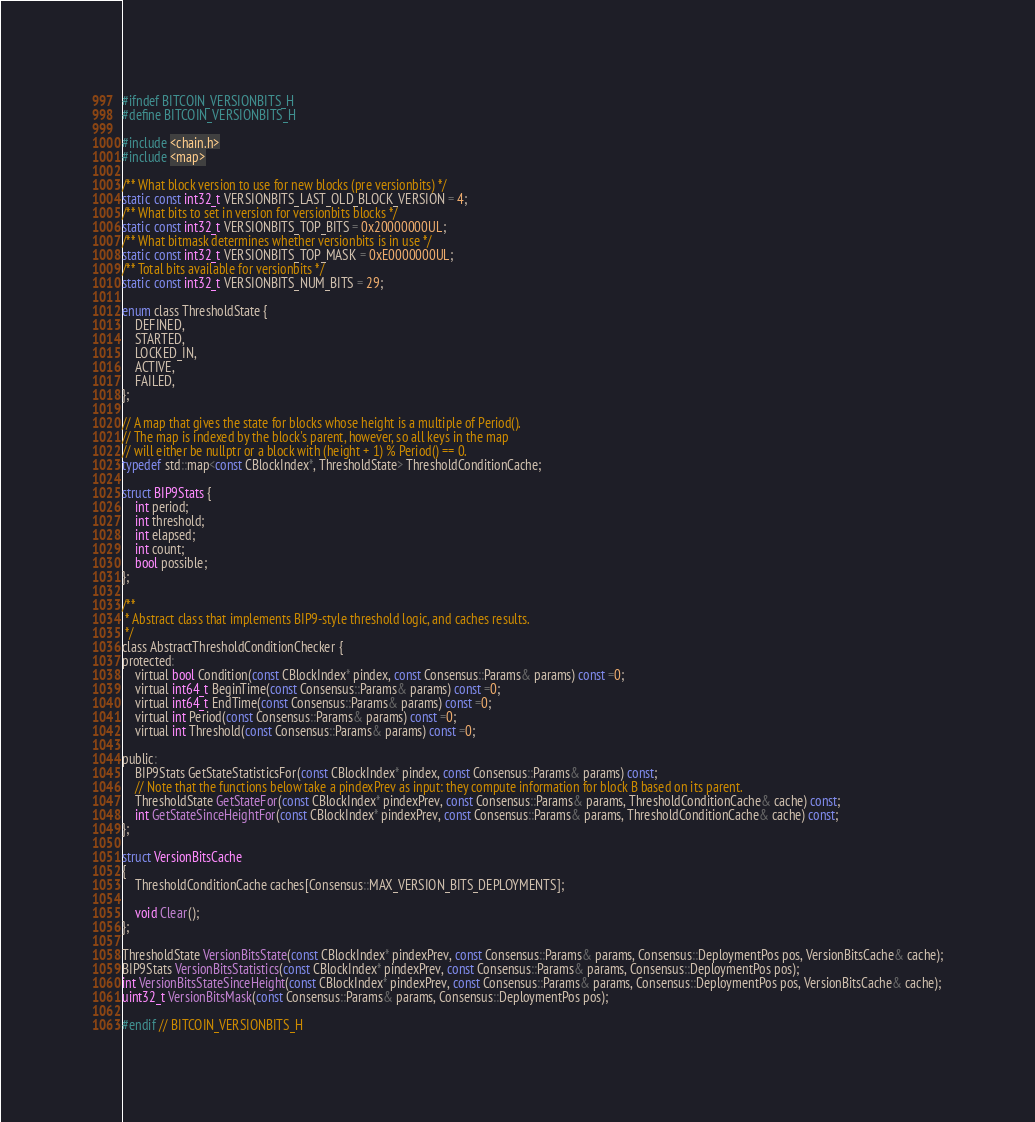Convert code to text. <code><loc_0><loc_0><loc_500><loc_500><_C_>
#ifndef BITCOIN_VERSIONBITS_H
#define BITCOIN_VERSIONBITS_H

#include <chain.h>
#include <map>

/** What block version to use for new blocks (pre versionbits) */
static const int32_t VERSIONBITS_LAST_OLD_BLOCK_VERSION = 4;
/** What bits to set in version for versionbits blocks */
static const int32_t VERSIONBITS_TOP_BITS = 0x20000000UL;
/** What bitmask determines whether versionbits is in use */
static const int32_t VERSIONBITS_TOP_MASK = 0xE0000000UL;
/** Total bits available for versionbits */
static const int32_t VERSIONBITS_NUM_BITS = 29;

enum class ThresholdState {
    DEFINED,
    STARTED,
    LOCKED_IN,
    ACTIVE,
    FAILED,
};

// A map that gives the state for blocks whose height is a multiple of Period().
// The map is indexed by the block's parent, however, so all keys in the map
// will either be nullptr or a block with (height + 1) % Period() == 0.
typedef std::map<const CBlockIndex*, ThresholdState> ThresholdConditionCache;

struct BIP9Stats {
    int period;
    int threshold;
    int elapsed;
    int count;
    bool possible;
};

/**
 * Abstract class that implements BIP9-style threshold logic, and caches results.
 */
class AbstractThresholdConditionChecker {
protected:
    virtual bool Condition(const CBlockIndex* pindex, const Consensus::Params& params) const =0;
    virtual int64_t BeginTime(const Consensus::Params& params) const =0;
    virtual int64_t EndTime(const Consensus::Params& params) const =0;
    virtual int Period(const Consensus::Params& params) const =0;
    virtual int Threshold(const Consensus::Params& params) const =0;

public:
    BIP9Stats GetStateStatisticsFor(const CBlockIndex* pindex, const Consensus::Params& params) const;
    // Note that the functions below take a pindexPrev as input: they compute information for block B based on its parent.
    ThresholdState GetStateFor(const CBlockIndex* pindexPrev, const Consensus::Params& params, ThresholdConditionCache& cache) const;
    int GetStateSinceHeightFor(const CBlockIndex* pindexPrev, const Consensus::Params& params, ThresholdConditionCache& cache) const;
};

struct VersionBitsCache
{
    ThresholdConditionCache caches[Consensus::MAX_VERSION_BITS_DEPLOYMENTS];

    void Clear();
};

ThresholdState VersionBitsState(const CBlockIndex* pindexPrev, const Consensus::Params& params, Consensus::DeploymentPos pos, VersionBitsCache& cache);
BIP9Stats VersionBitsStatistics(const CBlockIndex* pindexPrev, const Consensus::Params& params, Consensus::DeploymentPos pos);
int VersionBitsStateSinceHeight(const CBlockIndex* pindexPrev, const Consensus::Params& params, Consensus::DeploymentPos pos, VersionBitsCache& cache);
uint32_t VersionBitsMask(const Consensus::Params& params, Consensus::DeploymentPos pos);

#endif // BITCOIN_VERSIONBITS_H
</code> 